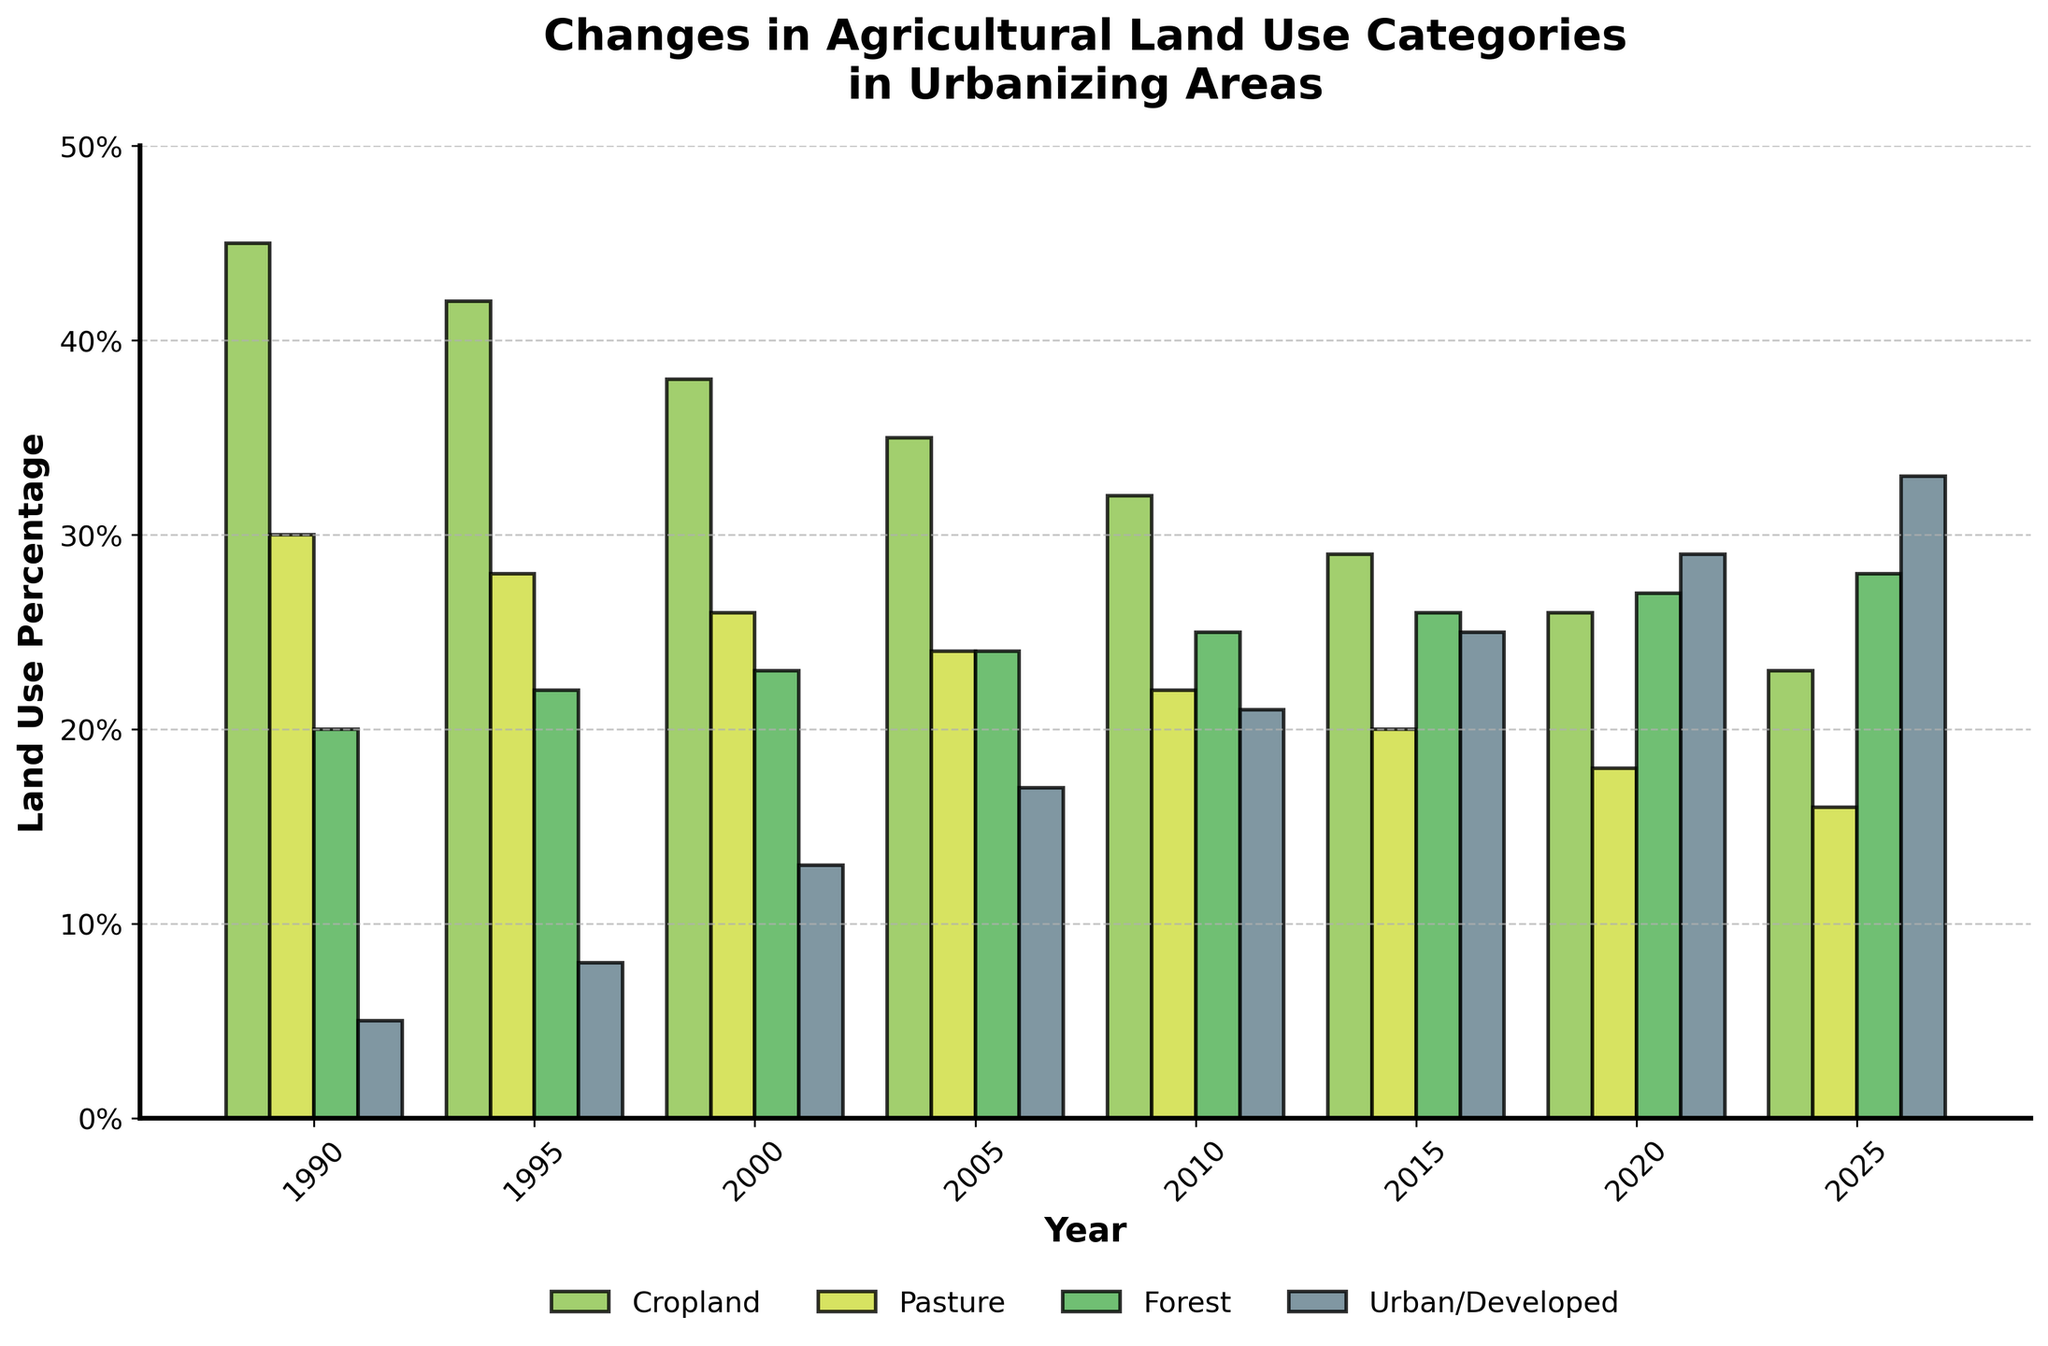Which land use category had the highest percentage in 1990? The bar corresponding to Cropland in 1990 is the tallest, indicating it has the highest percentage.
Answer: Cropland How did the Urban/Developed land use category change from 1990 to 2025? The bar for Urban/Developed starts at 5% in 1990 and increases steadily through the years, reaching 33% in 2025.
Answer: Increased from 5% to 33% By how much did Cropland decrease from 1990 to 2025? Cropland started at 45% in 1990 and decreased to 23% in 2025. The decrease is 45% - 23% = 22%.
Answer: 22% Which year first saw Forest land use surpass Cropland? By looking at the bars for both Forest and Cropland, 2000 is the first year where the Forest category is taller than Cropland.
Answer: 2020 What is the trend for Pasture land use from 1990 to 2025? The bars for Pasture decrease in height from 30% in 1990 to 16% in 2025, indicating a decreasing trend in Pasture land use.
Answer: Decreasing In which year was the percentage of Forest land exactly 25%? The bars show that the Forest land use was 25% in 2010.
Answer: 2010 Compare the percentages of Urban/Developed and Forest land use in 2015. The bar for Urban/Developed in 2015 is 25%, and the bar for Forest is 26%. Therefore, Forest is slightly higher than Urban/Developed in 2015.
Answer: Forest is slightly higher than Urban/Developed What year saw the largest decrease in percentage for Cropland? The largest single decrease in Cropland is between 1990 and 1995, where it dropped from 45% to 42%, a 3% decrease.
Answer: 1990 to 1995 In 2020, what’s the combined percentage of Cropland and Pasture? In 2020, Cropland is 26% and Pasture is 18%. The combined percentage is 26% + 18% = 44%.
Answer: 44% What is the ratio of Forest to Urban/Developed land in 1995? In 1995, Forest is 22% and Urban/Developed is 8%. The ratio is 22% / 8% = 2.75.
Answer: 2.75 